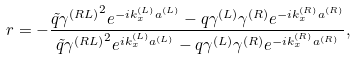<formula> <loc_0><loc_0><loc_500><loc_500>r = - \frac { \tilde { q } { \gamma ^ { ( R L ) } } ^ { 2 } e ^ { - i k _ { x } ^ { ( L ) } a ^ { ( L ) } } - q \gamma ^ { ( L ) } \gamma ^ { ( R ) } e ^ { - i k _ { x } ^ { ( R ) } a ^ { ( R ) } } } { \tilde { q } { \gamma ^ { ( R L ) } } ^ { 2 } e ^ { i k _ { x } ^ { ( L ) } a ^ { ( L ) } } - q \gamma ^ { ( L ) } \gamma ^ { ( R ) } e ^ { - i k _ { x } ^ { ( R ) } a ^ { ( R ) } } } ,</formula> 